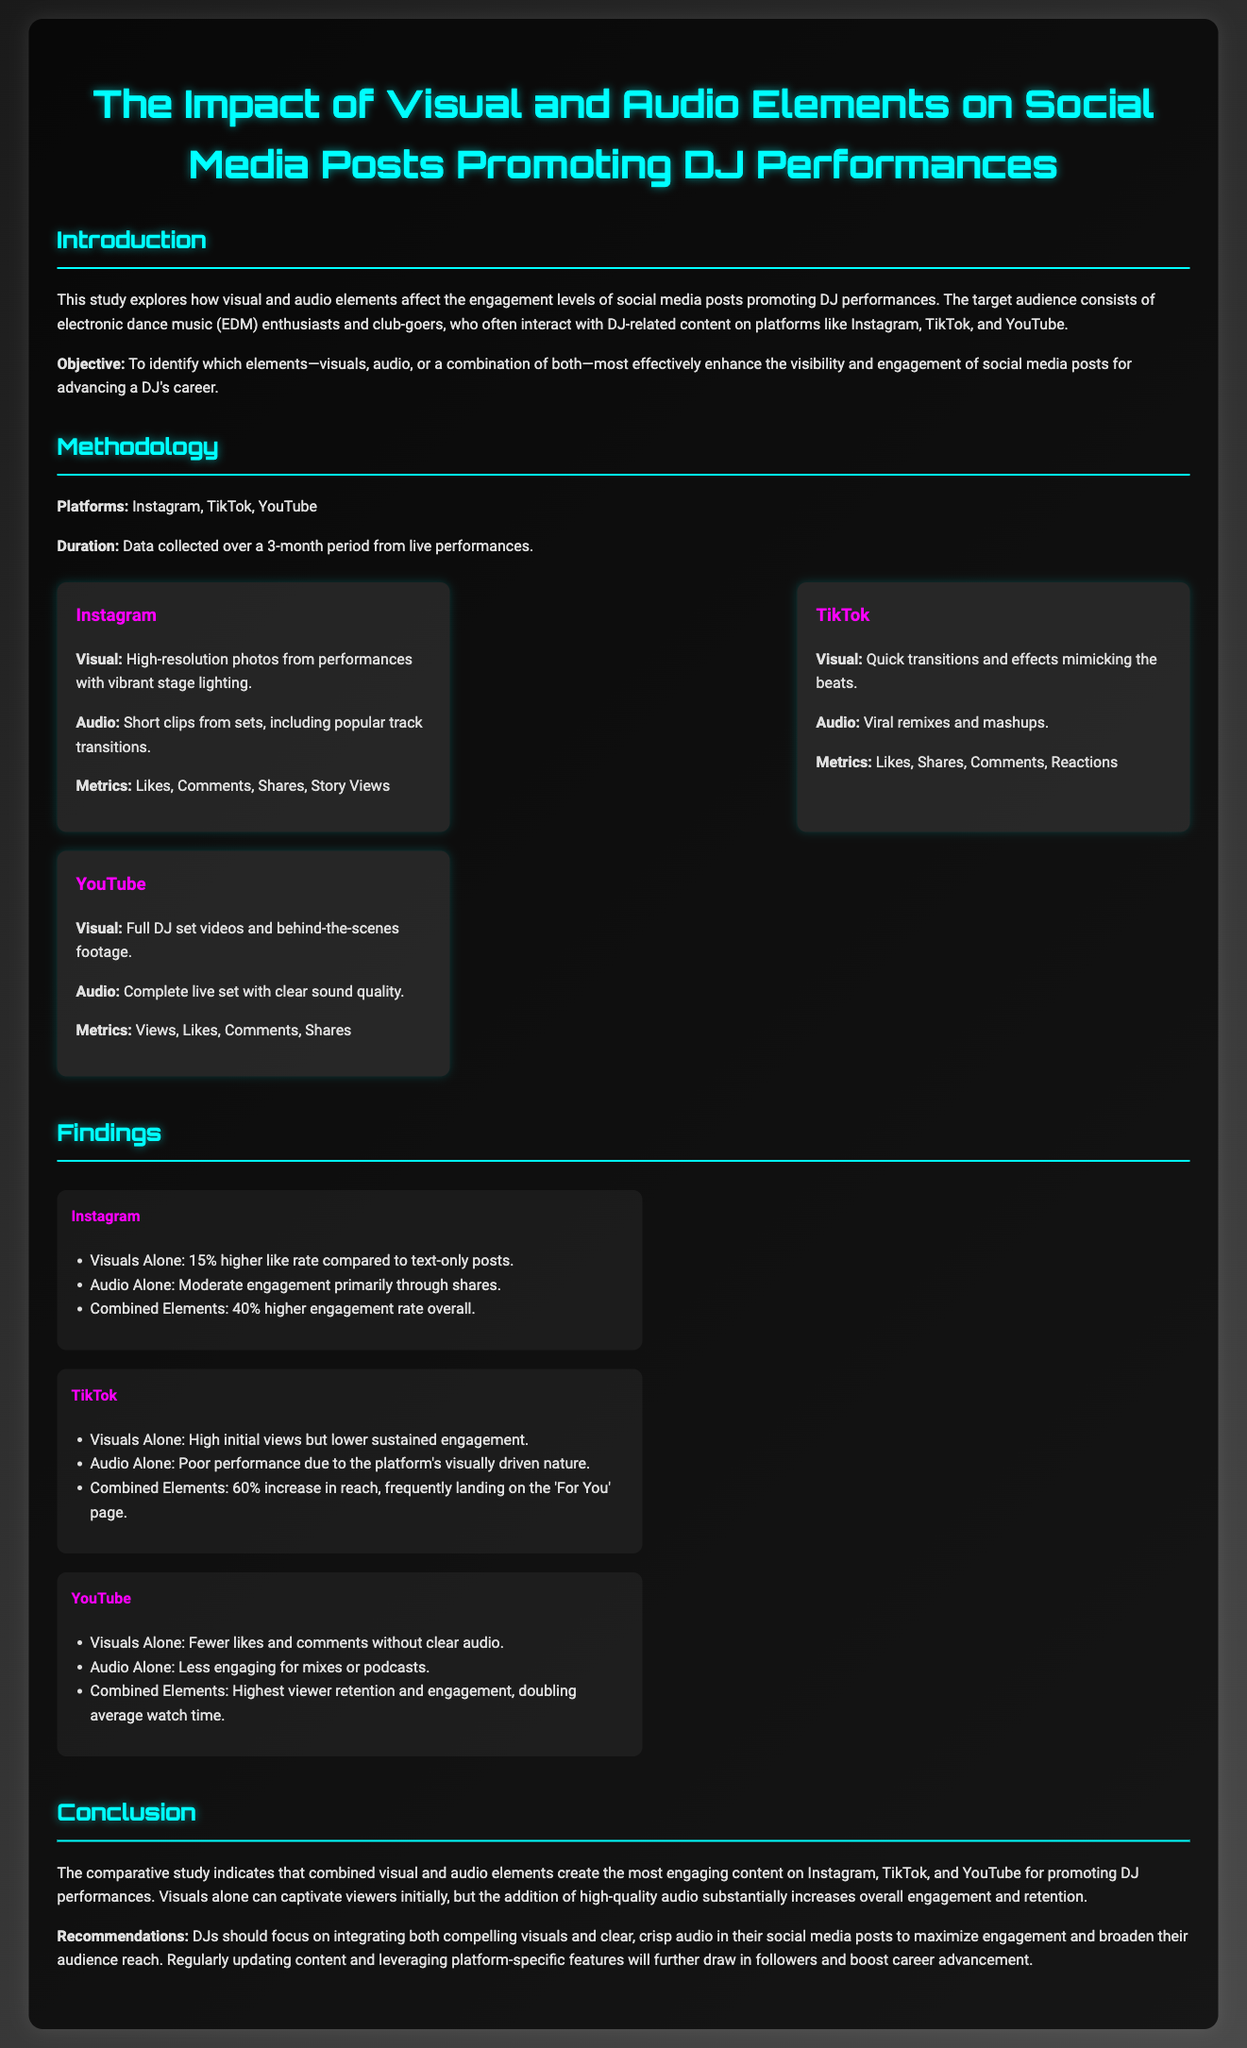what is the title of the study? The title summarizes the focus of the research on social media posts promoting DJ performances.
Answer: The Impact of Visual and Audio Elements on Social Media Posts Promoting DJ Performances what is the duration of data collection? The duration indicates how long the data was collected for the study.
Answer: 3-month period which platform had the highest combined engagement rate? The findings section compares the engagement rates across platforms, indicating TikTok's performance.
Answer: TikTok what percentage increase in reach was noted for TikTok with combined elements? This figure quantifies the effect of combining visual and audio elements on TikTok's engagement.
Answer: 60% what are the metrics used for Instagram? It lists the measurable outcomes relevant to Instagram posts in the study.
Answer: Likes, Comments, Shares, Story Views which element performed poorly on TikTok when used alone? The answer highlights the audio’s effectiveness or lack thereof on the platform.
Answer: Audio Alone what is the recommendation for DJs in the conclusion? This summarizes the key advice given to DJs based on study findings.
Answer: Integrating both compelling visuals and clear, crisp audio which platform's findings indicate doubling average watch time? This specifies which platform experienced the highest viewer retention and engagement from the findings.
Answer: YouTube 